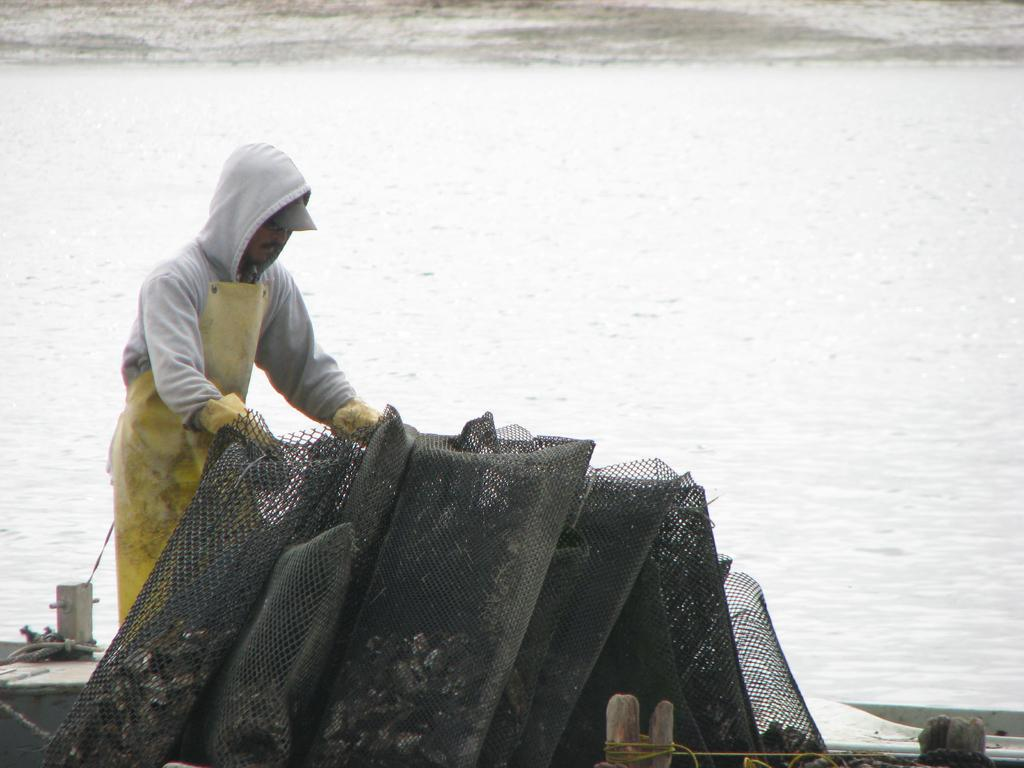What is the man in the image doing? The man is standing in the bottom left side of the image and holding fencing. What is the man holding in the image? The man is holding fencing. What can be seen behind the man in the image? There is water visible behind the man. What type of pin can be seen on the man's shirt in the image? There is no mention of a pin on the man's shirt in the image. Is there a bomb visible in the image? No, there is no bomb visible in the image. 